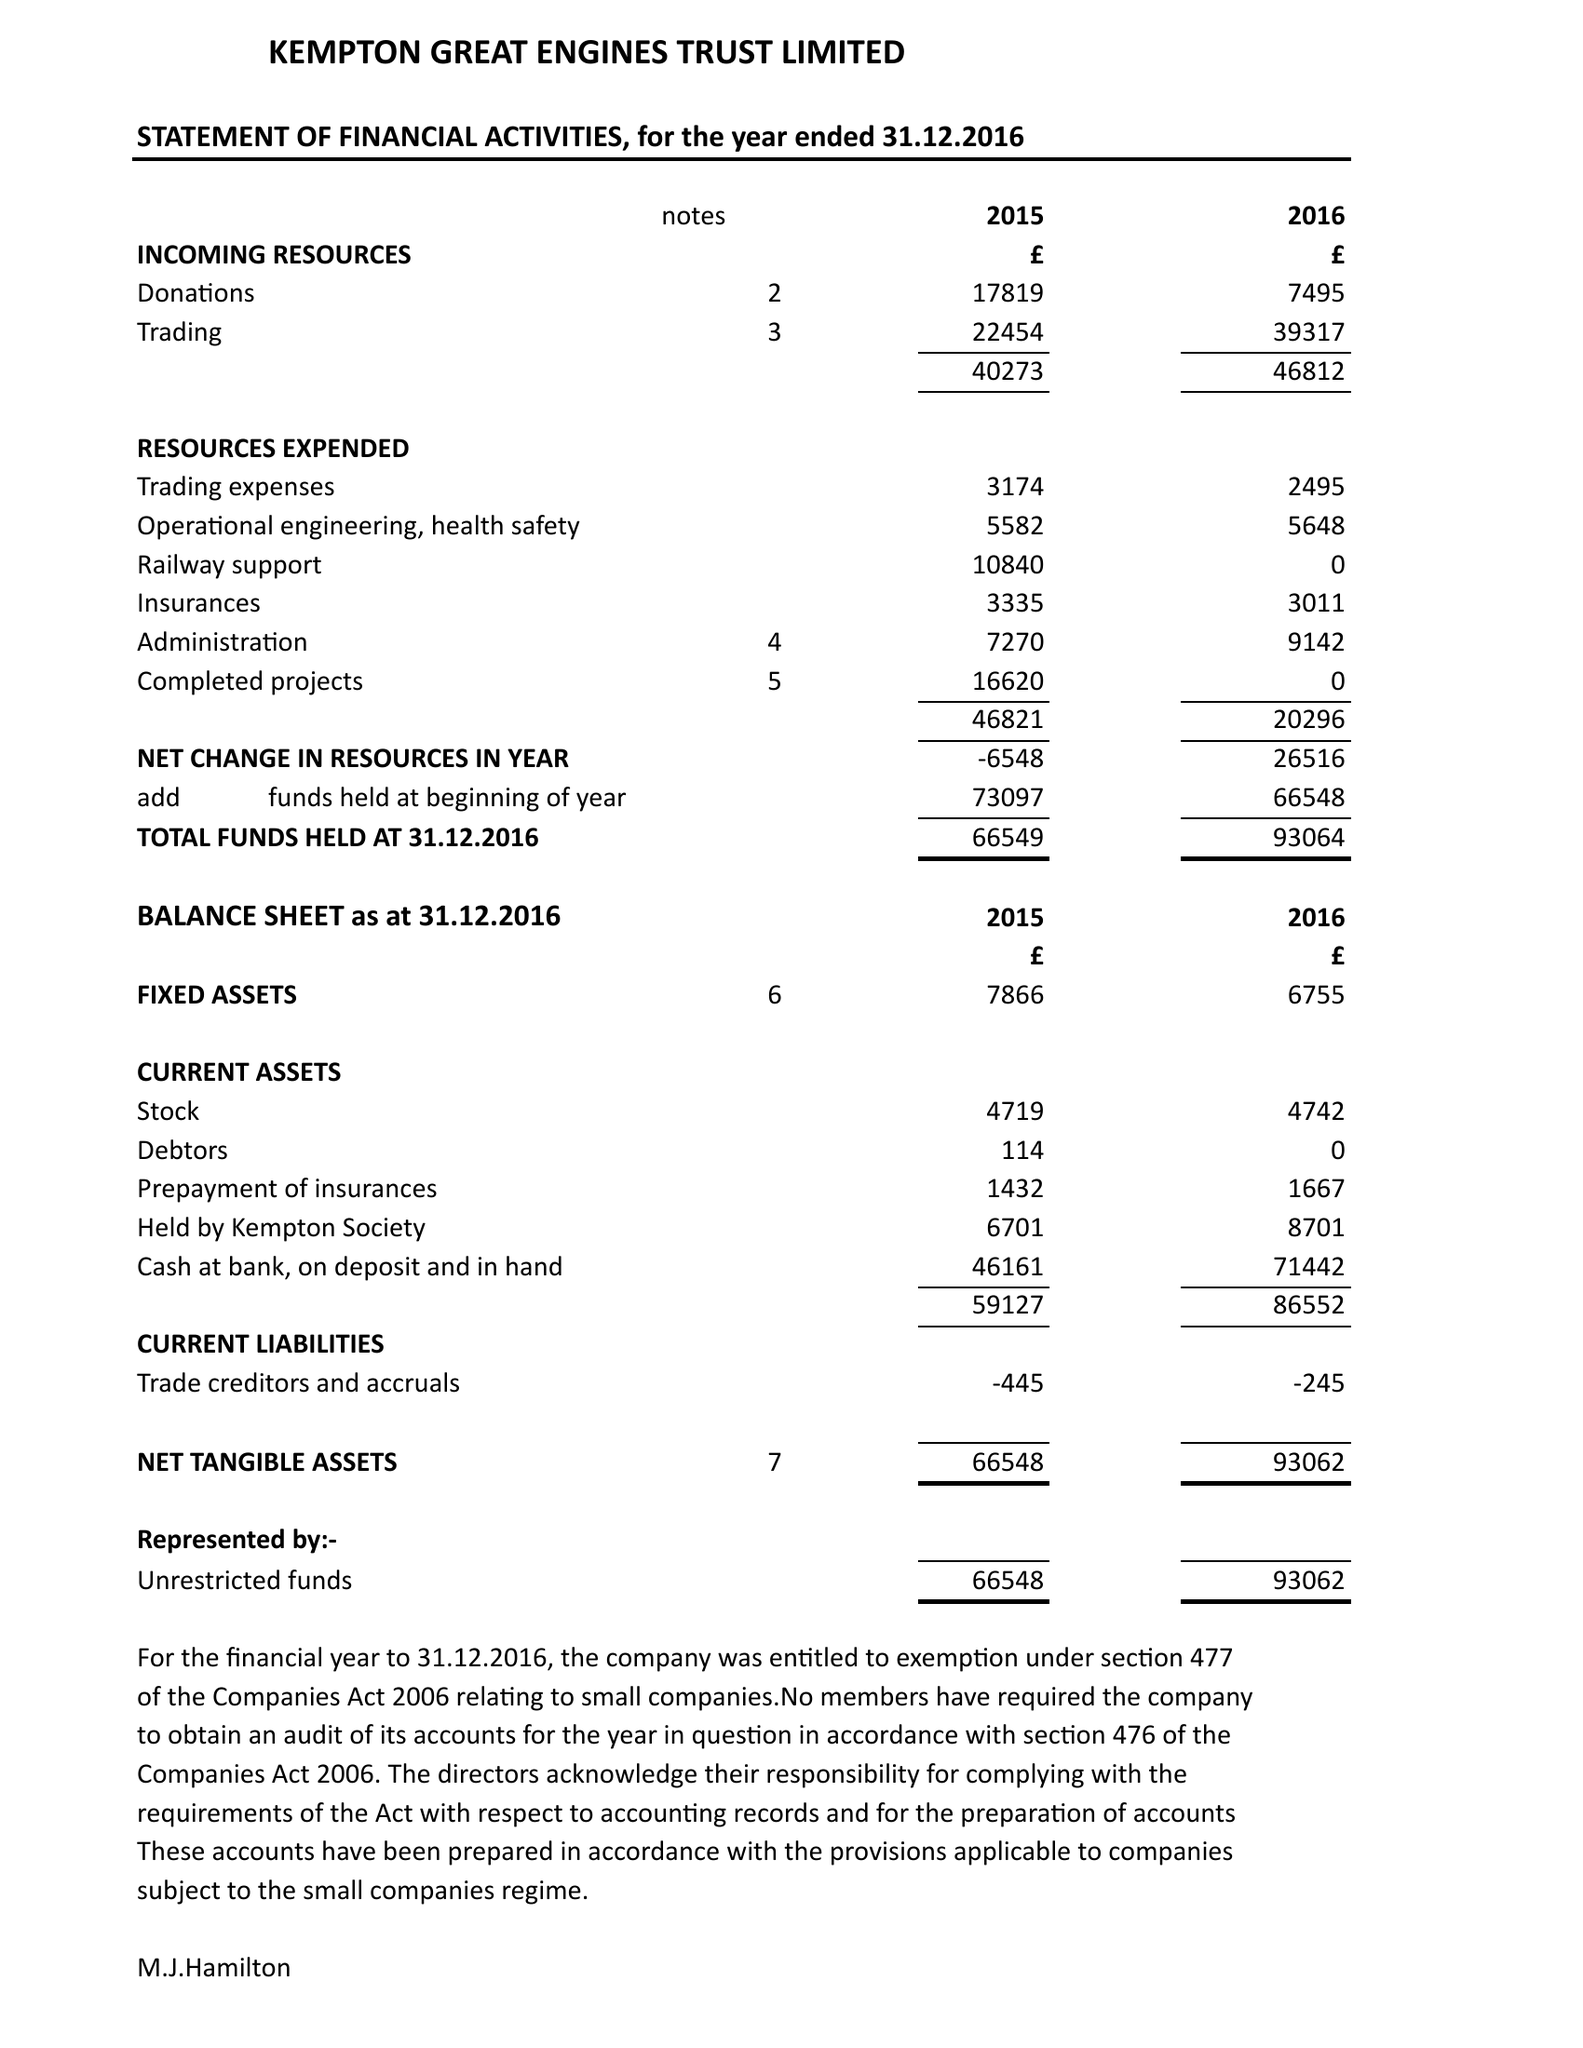What is the value for the report_date?
Answer the question using a single word or phrase. 2016-12-31 